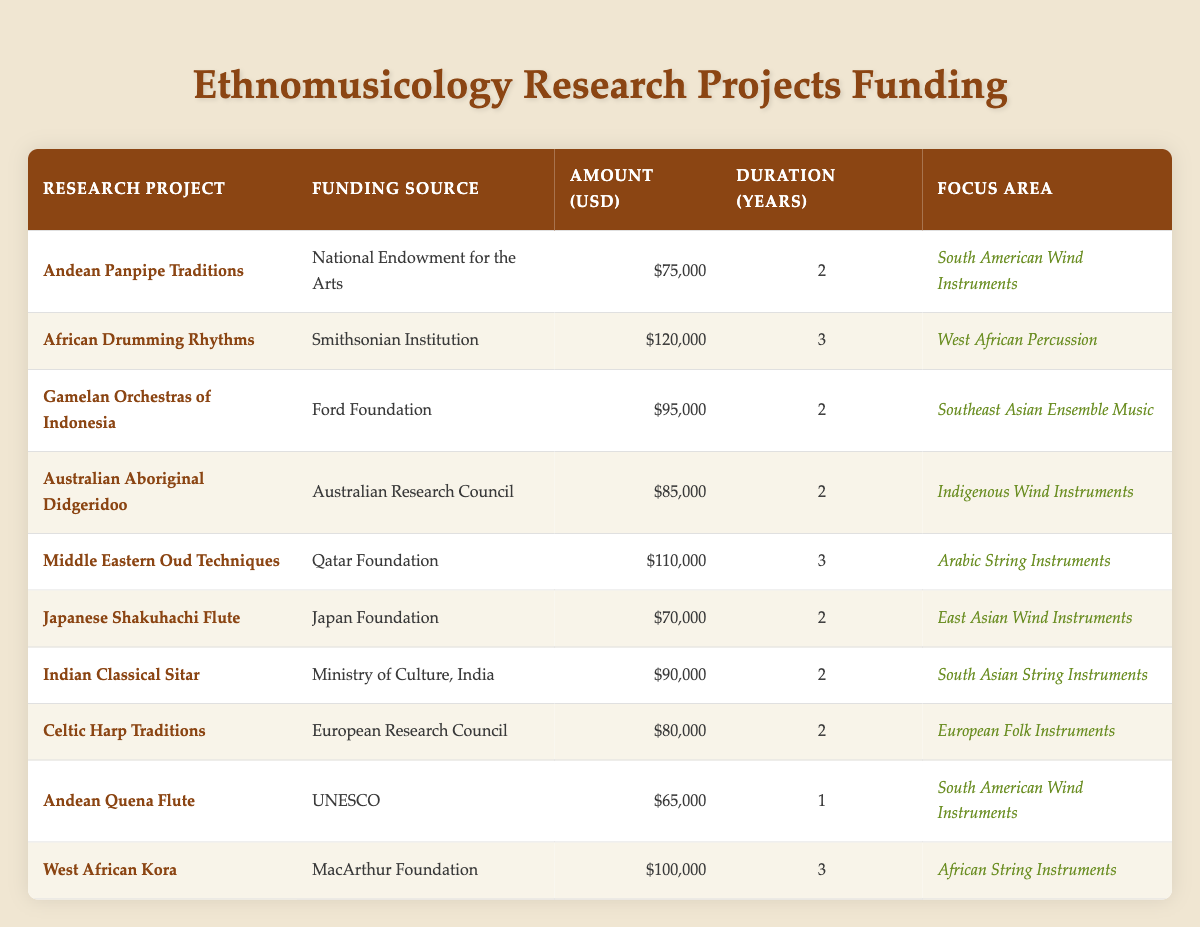What is the funding amount for the "Gamelan Orchestras of Indonesia" project? By locating the row for "Gamelan Orchestras of Indonesia", one can see that the corresponding funding amount is 95000 USD.
Answer: 95000 Which project has the highest funding amount? By reviewing the funding amounts for each project, it is clear that "African Drumming Rhythms" has the highest funding amount of 120000 USD.
Answer: African Drumming Rhythms How many projects are funded for a duration of 3 years? Upon counting the rows that indicate a duration of 3 years, there are three projects: "African Drumming Rhythms", "Middle Eastern Oud Techniques", and "West African Kora".
Answer: 3 What is the average funding amount of all projects focused on South American Wind Instruments? The projects focused on South American Wind Instruments are "Andean Panpipe Traditions" (75000 USD) and "Andean Quena Flute" (65000 USD). Adding these amounts gives 75000 + 65000 = 140000 USD. The average is then 140000 divided by 2 which equals 70000 USD.
Answer: 70000 Is there any project funded by the Japan Foundation? By checking the funding source column, it is confirmed that "Japanese Shakuhachi Flute" is funded by the Japan Foundation.
Answer: Yes Which focus area has the most funding disbursed? To determine the focus area with the most funding, we can add the funding amounts for each focus area. South American Wind Instruments: 75000 + 65000 = 140000 USD; West African Percussion: 120000 USD; Southeast Asian Ensemble Music: 95000 USD; Indigenous Wind Instruments: 85000 USD; Arabic String Instruments: 110000 USD; East Asian Wind Instruments: 70000 USD; South Asian String Instruments: 90000 USD; European Folk Instruments: 80000 USD; African String Instruments: 100000 USD. The highest total is 120000 USD for West African Percussion from the project "African Drumming Rhythms".
Answer: West African Percussion How much total funding is allocated for projects lasting 2 years? The projects lasting 2 years are "Andean Panpipe Traditions" (75000), "Gamelan Orchestras of Indonesia" (95000), "Australian Aboriginal Didgeridoo" (85000), "Japanese Shakuhachi Flute" (70000), "Indian Classical Sitar" (90000), and "Celtic Harp Traditions" (80000). Summing these amounts gives: 75000 + 95000 + 85000 + 70000 + 90000 + 80000 = 415000 USD.
Answer: 415000 What is the duration of the "Indian Classical Sitar" project? By finding the row for "Indian Classical Sitar", it shows a duration of 2 years.
Answer: 2 